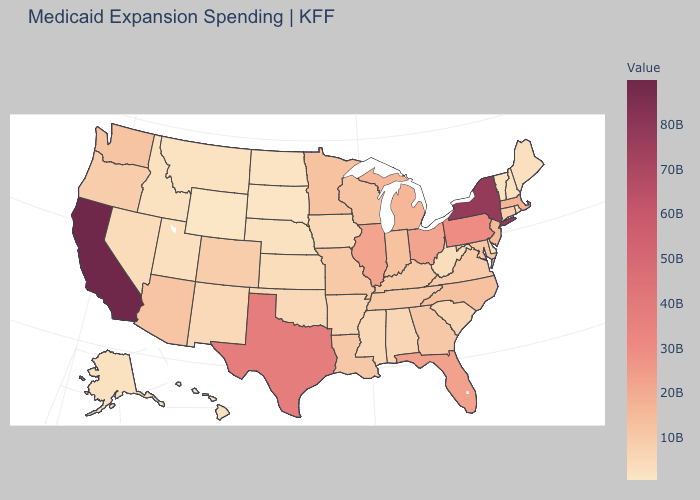Which states have the highest value in the USA?
Keep it brief. California. Which states have the highest value in the USA?
Answer briefly. California. Among the states that border Nebraska , which have the lowest value?
Be succinct. Wyoming. Does Wyoming have the lowest value in the USA?
Quick response, please. Yes. Does Ohio have the lowest value in the USA?
Write a very short answer. No. Does Illinois have the highest value in the USA?
Keep it brief. No. Which states have the highest value in the USA?
Keep it brief. California. 